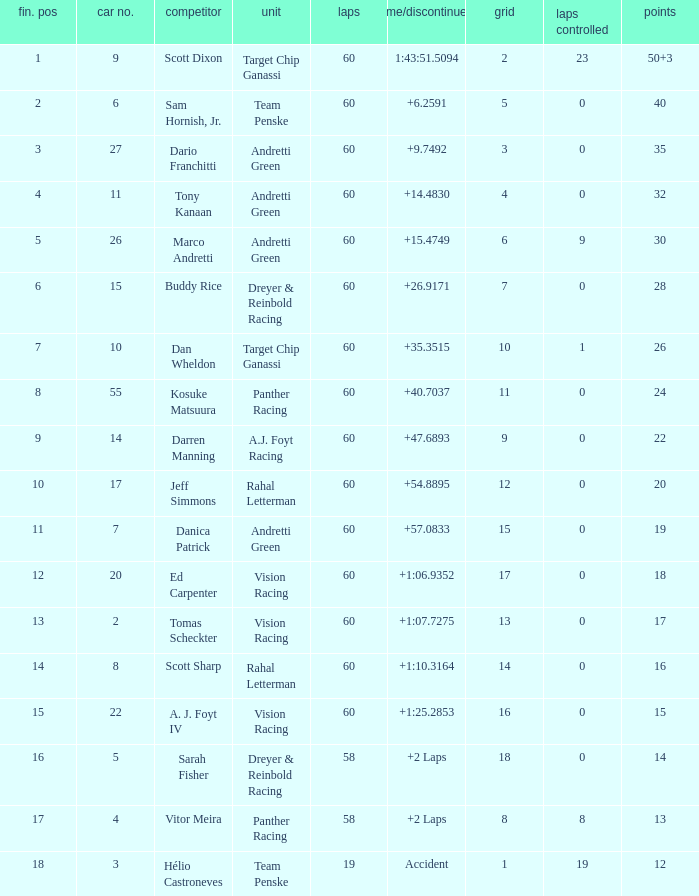Could you help me parse every detail presented in this table? {'header': ['fin. pos', 'car no.', 'competitor', 'unit', 'laps', 'time/discontinued', 'grid', 'laps controlled', 'points'], 'rows': [['1', '9', 'Scott Dixon', 'Target Chip Ganassi', '60', '1:43:51.5094', '2', '23', '50+3'], ['2', '6', 'Sam Hornish, Jr.', 'Team Penske', '60', '+6.2591', '5', '0', '40'], ['3', '27', 'Dario Franchitti', 'Andretti Green', '60', '+9.7492', '3', '0', '35'], ['4', '11', 'Tony Kanaan', 'Andretti Green', '60', '+14.4830', '4', '0', '32'], ['5', '26', 'Marco Andretti', 'Andretti Green', '60', '+15.4749', '6', '9', '30'], ['6', '15', 'Buddy Rice', 'Dreyer & Reinbold Racing', '60', '+26.9171', '7', '0', '28'], ['7', '10', 'Dan Wheldon', 'Target Chip Ganassi', '60', '+35.3515', '10', '1', '26'], ['8', '55', 'Kosuke Matsuura', 'Panther Racing', '60', '+40.7037', '11', '0', '24'], ['9', '14', 'Darren Manning', 'A.J. Foyt Racing', '60', '+47.6893', '9', '0', '22'], ['10', '17', 'Jeff Simmons', 'Rahal Letterman', '60', '+54.8895', '12', '0', '20'], ['11', '7', 'Danica Patrick', 'Andretti Green', '60', '+57.0833', '15', '0', '19'], ['12', '20', 'Ed Carpenter', 'Vision Racing', '60', '+1:06.9352', '17', '0', '18'], ['13', '2', 'Tomas Scheckter', 'Vision Racing', '60', '+1:07.7275', '13', '0', '17'], ['14', '8', 'Scott Sharp', 'Rahal Letterman', '60', '+1:10.3164', '14', '0', '16'], ['15', '22', 'A. J. Foyt IV', 'Vision Racing', '60', '+1:25.2853', '16', '0', '15'], ['16', '5', 'Sarah Fisher', 'Dreyer & Reinbold Racing', '58', '+2 Laps', '18', '0', '14'], ['17', '4', 'Vitor Meira', 'Panther Racing', '58', '+2 Laps', '8', '8', '13'], ['18', '3', 'Hélio Castroneves', 'Team Penske', '19', 'Accident', '1', '19', '12']]} Name the team of darren manning A.J. Foyt Racing. 